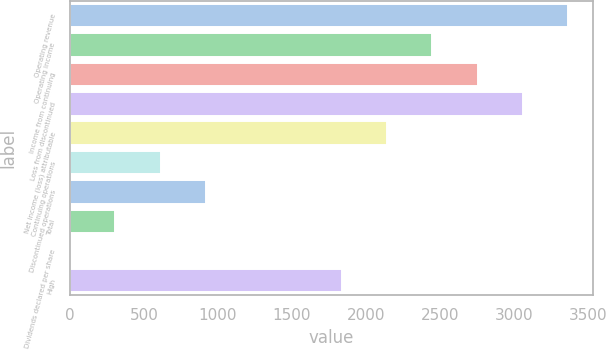Convert chart to OTSL. <chart><loc_0><loc_0><loc_500><loc_500><bar_chart><fcel>Operating revenue<fcel>Operating income<fcel>Income from continuing<fcel>Loss from discontinued<fcel>Net income (loss) attributable<fcel>Continuing operations<fcel>Discontinued operations<fcel>Total<fcel>Dividends declared per share<fcel>High<nl><fcel>3366.01<fcel>2448.1<fcel>2754.07<fcel>3060.04<fcel>2142.13<fcel>612.28<fcel>918.25<fcel>306.31<fcel>0.34<fcel>1836.16<nl></chart> 